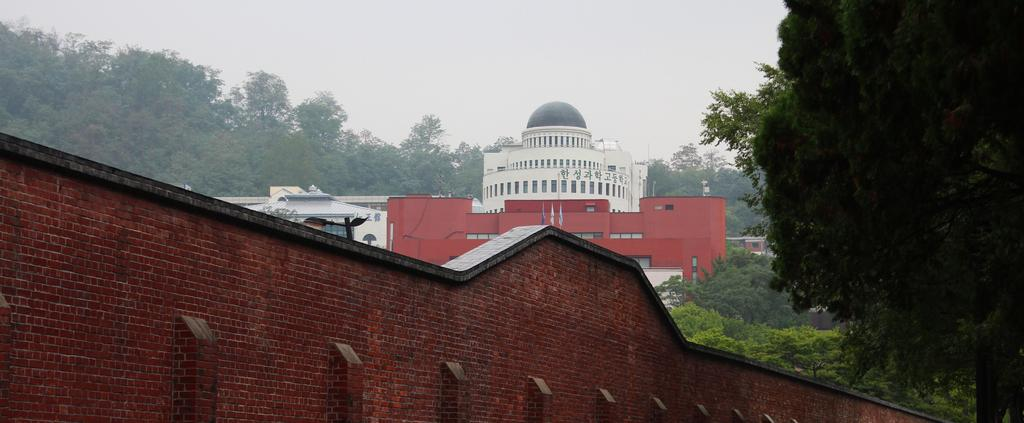What type of structure can be seen in the image? There is a wall in the image. What is the color of the wall? The wall is in brick color. What can be seen in the background of the image? There are buildings and trees in the background of the image. What type of plate is being used to hold the beam in the image? A: There is no plate or beam present in the image; it only features a wall and the background. 